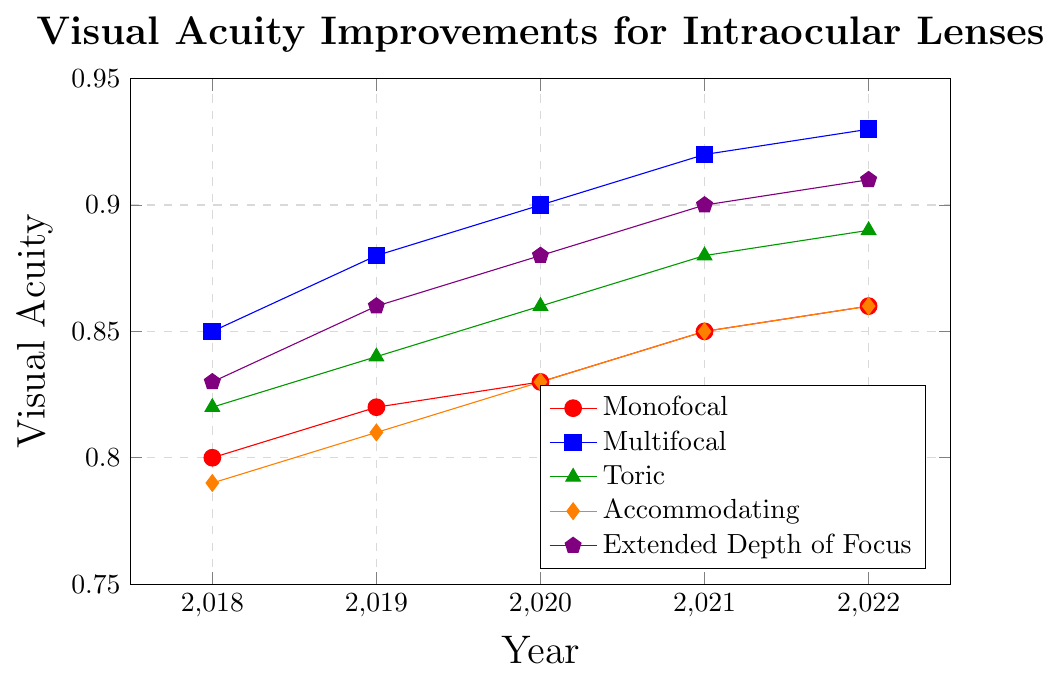Which type of intraocular lens shows the greatest improvement in visual acuity over the 5-year period? To determine this, subtract the visual acuity value in 2018 from the value in 2022 for each lens. Monofocal: 0.86 - 0.8 = 0.06, Multifocal: 0.93 - 0.85 = 0.08, Toric: 0.89 - 0.82 = 0.07, Accommodating: 0.86 - 0.79 = 0.07, Extended Depth of Focus: 0.91 - 0.83 = 0.08. The highest improvement is 0.08 for Multifocal and Extended Depth of Focus lenses.
Answer: Multifocal and Extended Depth of Focus In what year did the Monofocal lens achieve a visual acuity of 0.85? Locate the year on the X-axis where the Monofocal line reaches a visual acuity of 0.85. According to the chart, this occurs in 2021.
Answer: 2021 By how much did the visual acuity of the Toric lens improve from 2018 to 2022? Subtract the visual acuity value in 2018 from the value in 2022 for the Toric lens. The improvement is 0.89 - 0.82 = 0.07.
Answer: 0.07 Which intraocular lens consistently had the highest visual acuity each year? Compare the visual acuity values for each year. Multifocal lens consistently had the highest visual acuity value every year: 0.85, 0.88, 0.9, 0.92, 0.93.
Answer: Multifocal Did the visual acuity for the Accommodating lens ever surpass 0.85? Check the visual acuity values for each year for the Accommodating lens. In 2021 and 2022, the values are 0.85 and 0.86.
Answer: Yes What is the average visual acuity for the Extended Depth of Focus lens over the 5 years? Sum the visual acuity values for each year and divide by 5. \( (0.83 + 0.86 + 0.88 + 0.9 + 0.91) / 5 = 4.38 / 5 = 0.876 \)
Answer: 0.876 Is there any year where the Accommodating lens performed better than the Monofocal lens? Compare the visual acuity values for each year between the Accommodating and Monofocal lenses: 2018 (0.79 < 0.8), 2019 (0.81 < 0.82), 2020 (0.83 = 0.83), 2021 (0.85 = 0.85), 2022 (0.86 = 0.86). Accommodating lens never performed better than Monofocal.
Answer: No What was the visual acuity of the Multifocal lens in 2020? Look directly at the value for the Multifocal lens for the year 2020, which is 0.9.
Answer: 0.9 